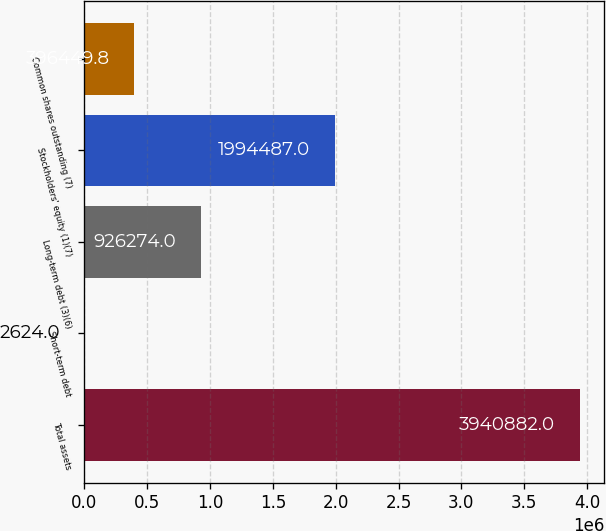Convert chart. <chart><loc_0><loc_0><loc_500><loc_500><bar_chart><fcel>Total assets<fcel>Short-term debt<fcel>Long-term debt (3)(6)<fcel>Stockholders' equity (1)(7)<fcel>Common shares outstanding (7)<nl><fcel>3.94088e+06<fcel>2624<fcel>926274<fcel>1.99449e+06<fcel>396450<nl></chart> 